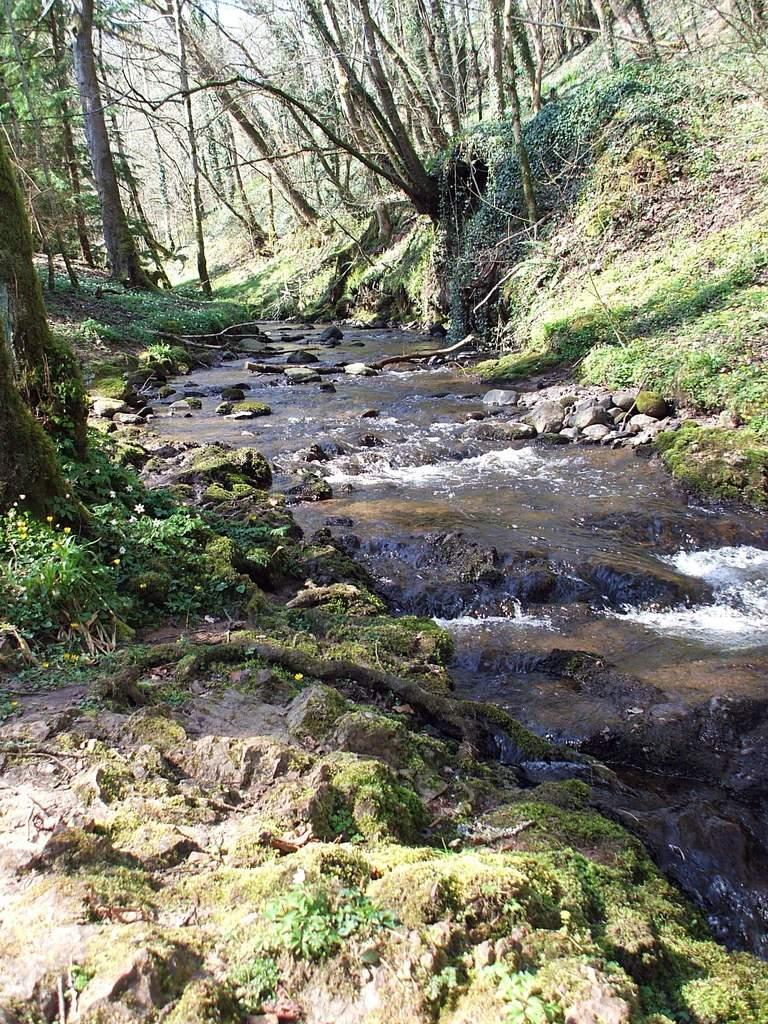What type of natural feature is present in the image? There is a river in the image. What other elements can be seen in the image? There are rocks, plants, and trees in the image. What is the texture of the division between the rocks and the plants in the image? There is no division between the rocks and the plants mentioned in the image, and therefore no texture can be described for it. 